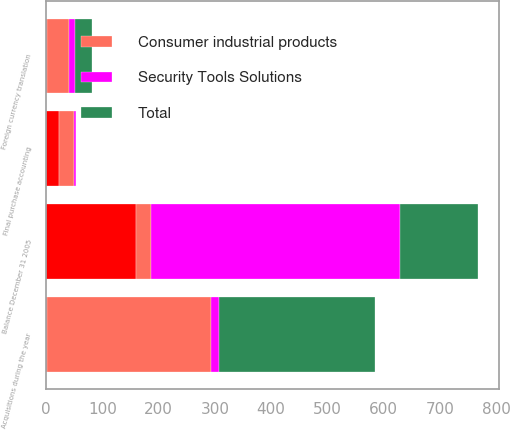<chart> <loc_0><loc_0><loc_500><loc_500><stacked_bar_chart><ecel><fcel>Balance December 31 2005<fcel>Acquisitions during the year<fcel>Final purchase accounting<fcel>Foreign currency translation<nl><fcel>nan<fcel>159.3<fcel>0.9<fcel>22.3<fcel>0.6<nl><fcel>Total<fcel>138.2<fcel>277<fcel>0.1<fcel>29.9<nl><fcel>Security Tools Solutions<fcel>443.4<fcel>14.7<fcel>4.4<fcel>10.6<nl><fcel>Consumer industrial products<fcel>26.8<fcel>292.6<fcel>26.8<fcel>39.9<nl></chart> 